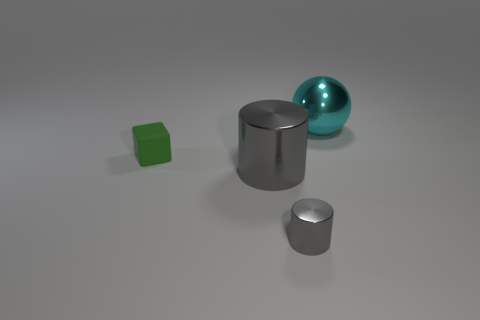Add 4 matte blocks. How many objects exist? 8 Subtract all balls. How many objects are left? 3 Add 4 small green cylinders. How many small green cylinders exist? 4 Subtract 1 cyan spheres. How many objects are left? 3 Subtract all shiny spheres. Subtract all small shiny things. How many objects are left? 2 Add 4 gray metal objects. How many gray metal objects are left? 6 